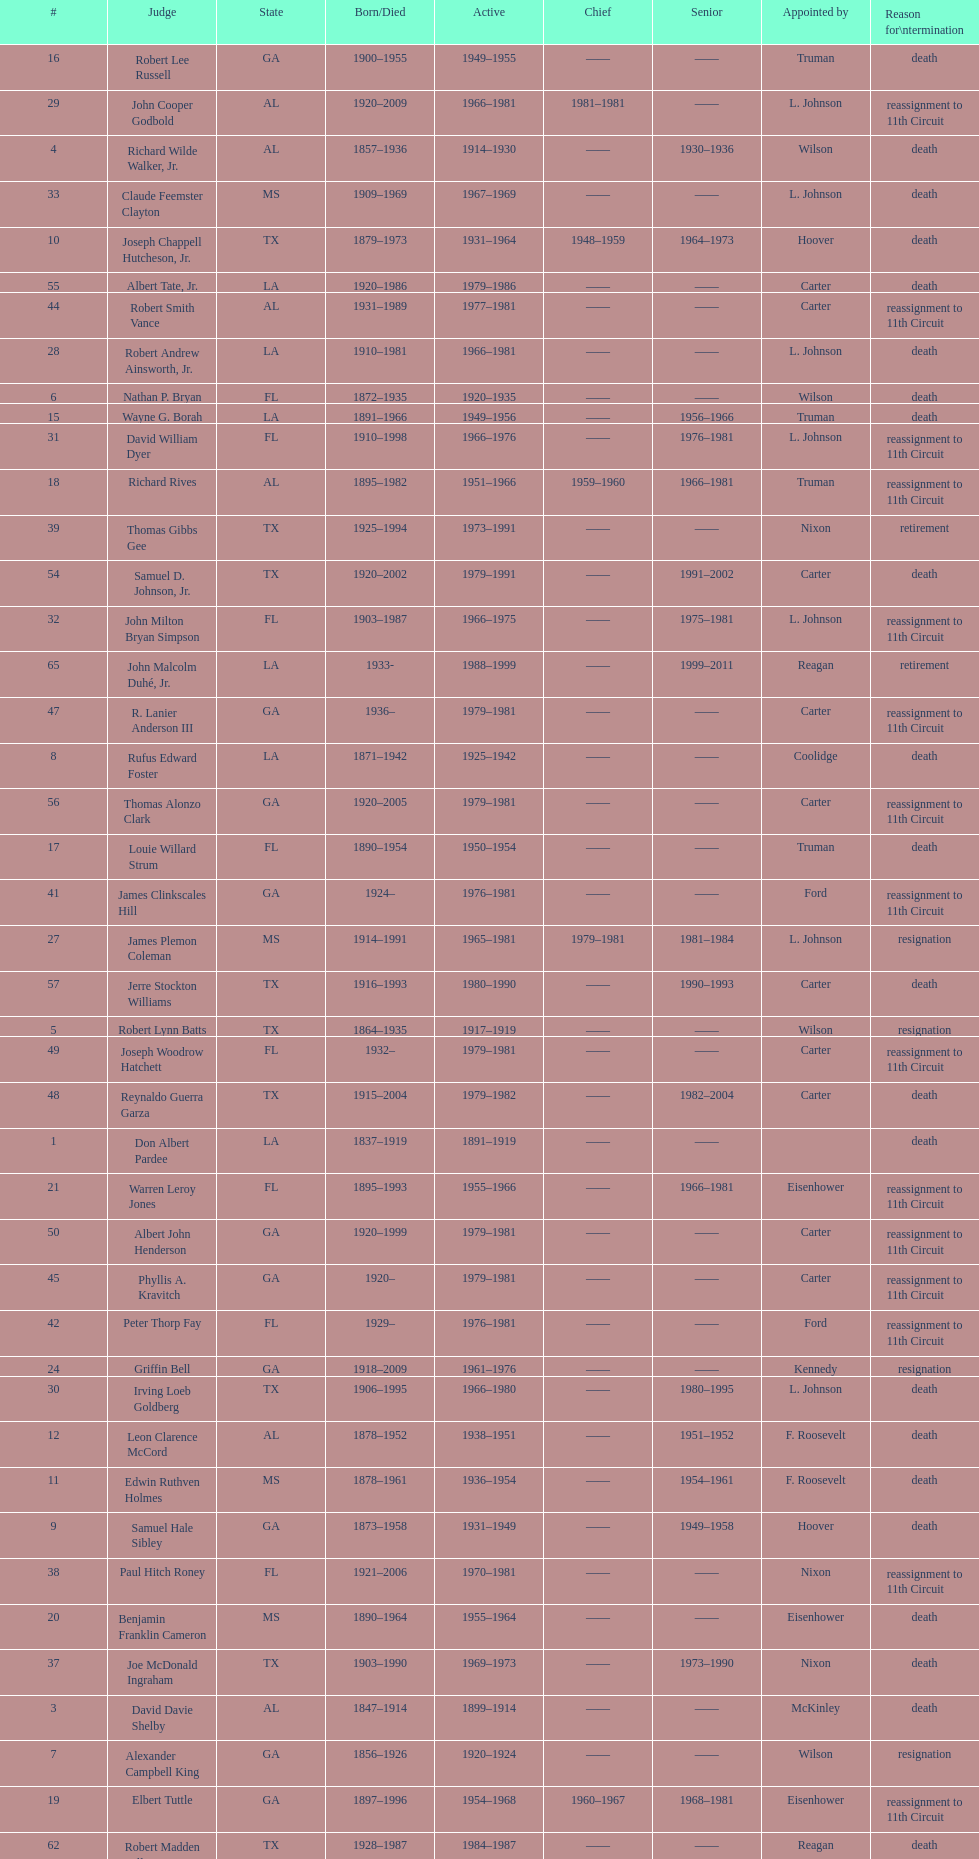How many judges served as chief total? 8. 